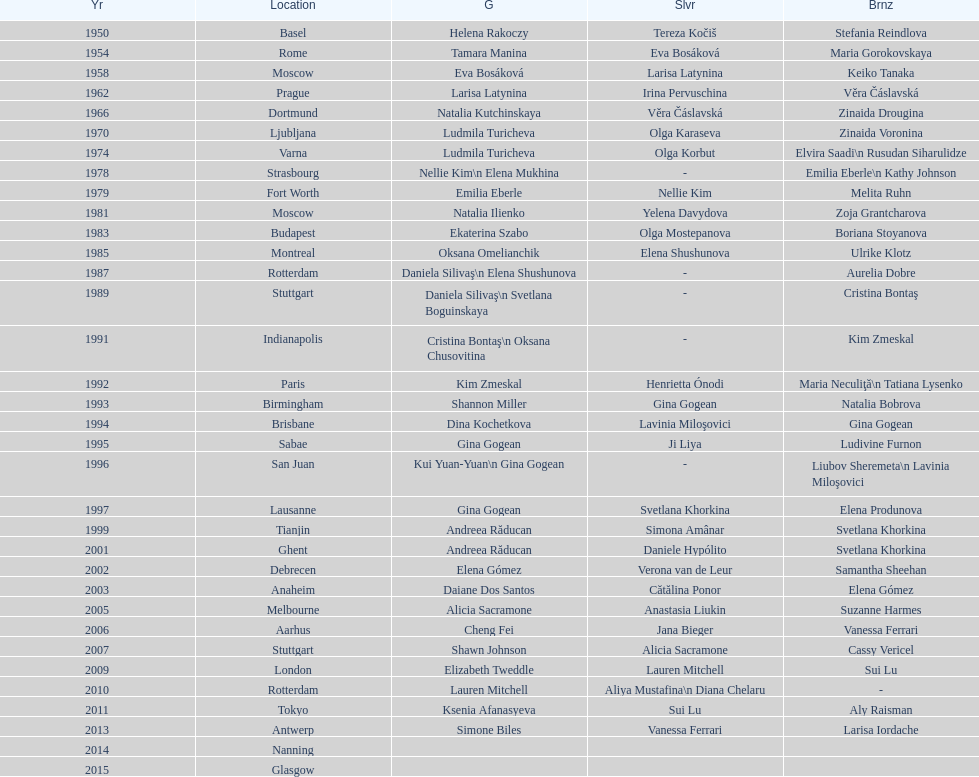How many consecutive floor exercise gold medals did romanian star andreea raducan win at the world championships? 2. 